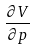Convert formula to latex. <formula><loc_0><loc_0><loc_500><loc_500>\frac { \partial V } { \partial p }</formula> 